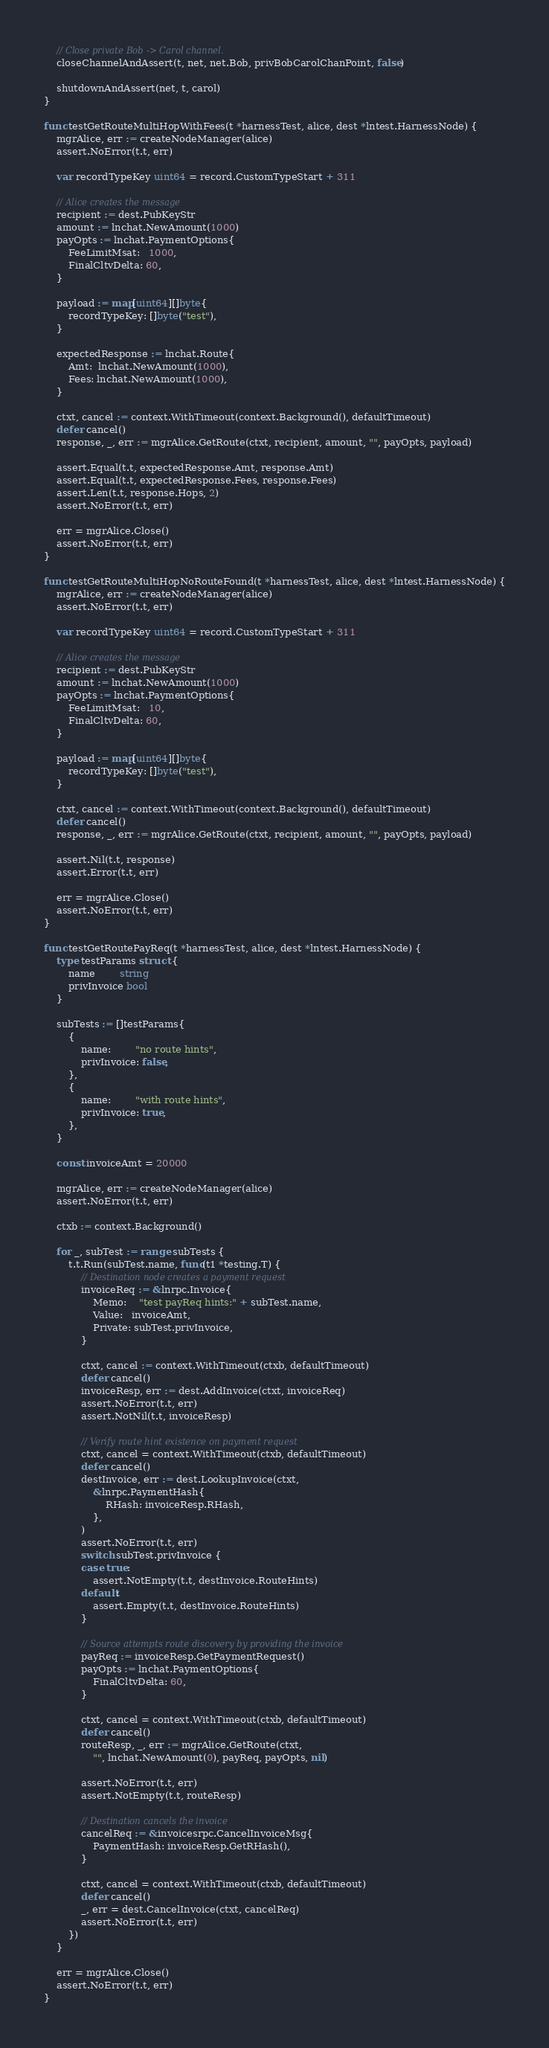<code> <loc_0><loc_0><loc_500><loc_500><_Go_>	// Close private Bob -> Carol channel.
	closeChannelAndAssert(t, net, net.Bob, privBobCarolChanPoint, false)

	shutdownAndAssert(net, t, carol)
}

func testGetRouteMultiHopWithFees(t *harnessTest, alice, dest *lntest.HarnessNode) {
	mgrAlice, err := createNodeManager(alice)
	assert.NoError(t.t, err)

	var recordTypeKey uint64 = record.CustomTypeStart + 311

	// Alice creates the message
	recipient := dest.PubKeyStr
	amount := lnchat.NewAmount(1000)
	payOpts := lnchat.PaymentOptions{
		FeeLimitMsat:   1000,
		FinalCltvDelta: 60,
	}

	payload := map[uint64][]byte{
		recordTypeKey: []byte("test"),
	}

	expectedResponse := lnchat.Route{
		Amt:  lnchat.NewAmount(1000),
		Fees: lnchat.NewAmount(1000),
	}

	ctxt, cancel := context.WithTimeout(context.Background(), defaultTimeout)
	defer cancel()
	response, _, err := mgrAlice.GetRoute(ctxt, recipient, amount, "", payOpts, payload)

	assert.Equal(t.t, expectedResponse.Amt, response.Amt)
	assert.Equal(t.t, expectedResponse.Fees, response.Fees)
	assert.Len(t.t, response.Hops, 2)
	assert.NoError(t.t, err)

	err = mgrAlice.Close()
	assert.NoError(t.t, err)
}

func testGetRouteMultiHopNoRouteFound(t *harnessTest, alice, dest *lntest.HarnessNode) {
	mgrAlice, err := createNodeManager(alice)
	assert.NoError(t.t, err)

	var recordTypeKey uint64 = record.CustomTypeStart + 311

	// Alice creates the message
	recipient := dest.PubKeyStr
	amount := lnchat.NewAmount(1000)
	payOpts := lnchat.PaymentOptions{
		FeeLimitMsat:   10,
		FinalCltvDelta: 60,
	}

	payload := map[uint64][]byte{
		recordTypeKey: []byte("test"),
	}

	ctxt, cancel := context.WithTimeout(context.Background(), defaultTimeout)
	defer cancel()
	response, _, err := mgrAlice.GetRoute(ctxt, recipient, amount, "", payOpts, payload)

	assert.Nil(t.t, response)
	assert.Error(t.t, err)

	err = mgrAlice.Close()
	assert.NoError(t.t, err)
}

func testGetRoutePayReq(t *harnessTest, alice, dest *lntest.HarnessNode) {
	type testParams struct {
		name        string
		privInvoice bool
	}

	subTests := []testParams{
		{
			name:        "no route hints",
			privInvoice: false,
		},
		{
			name:        "with route hints",
			privInvoice: true,
		},
	}

	const invoiceAmt = 20000

	mgrAlice, err := createNodeManager(alice)
	assert.NoError(t.t, err)

	ctxb := context.Background()

	for _, subTest := range subTests {
		t.t.Run(subTest.name, func(t1 *testing.T) {
			// Destination node creates a payment request
			invoiceReq := &lnrpc.Invoice{
				Memo:    "test payReq hints:" + subTest.name,
				Value:   invoiceAmt,
				Private: subTest.privInvoice,
			}

			ctxt, cancel := context.WithTimeout(ctxb, defaultTimeout)
			defer cancel()
			invoiceResp, err := dest.AddInvoice(ctxt, invoiceReq)
			assert.NoError(t.t, err)
			assert.NotNil(t.t, invoiceResp)

			// Verify route hint existence on payment request
			ctxt, cancel = context.WithTimeout(ctxb, defaultTimeout)
			defer cancel()
			destInvoice, err := dest.LookupInvoice(ctxt,
				&lnrpc.PaymentHash{
					RHash: invoiceResp.RHash,
				},
			)
			assert.NoError(t.t, err)
			switch subTest.privInvoice {
			case true:
				assert.NotEmpty(t.t, destInvoice.RouteHints)
			default:
				assert.Empty(t.t, destInvoice.RouteHints)
			}

			// Source attempts route discovery by providing the invoice
			payReq := invoiceResp.GetPaymentRequest()
			payOpts := lnchat.PaymentOptions{
				FinalCltvDelta: 60,
			}

			ctxt, cancel = context.WithTimeout(ctxb, defaultTimeout)
			defer cancel()
			routeResp, _, err := mgrAlice.GetRoute(ctxt,
				"", lnchat.NewAmount(0), payReq, payOpts, nil)

			assert.NoError(t.t, err)
			assert.NotEmpty(t.t, routeResp)

			// Destination cancels the invoice
			cancelReq := &invoicesrpc.CancelInvoiceMsg{
				PaymentHash: invoiceResp.GetRHash(),
			}

			ctxt, cancel = context.WithTimeout(ctxb, defaultTimeout)
			defer cancel()
			_, err = dest.CancelInvoice(ctxt, cancelReq)
			assert.NoError(t.t, err)
		})
	}

	err = mgrAlice.Close()
	assert.NoError(t.t, err)
}
</code> 